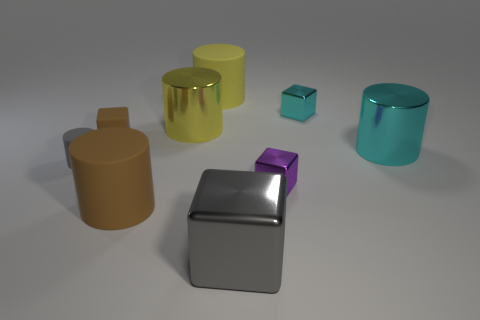Subtract all big brown matte cylinders. How many cylinders are left? 4 Subtract 1 blocks. How many blocks are left? 3 Subtract all brown cylinders. How many cylinders are left? 4 Subtract all brown cylinders. Subtract all purple cubes. How many cylinders are left? 4 Subtract all cubes. How many objects are left? 5 Subtract 1 cyan cylinders. How many objects are left? 8 Subtract all brown matte blocks. Subtract all gray things. How many objects are left? 6 Add 1 tiny matte cubes. How many tiny matte cubes are left? 2 Add 8 tiny purple matte cylinders. How many tiny purple matte cylinders exist? 8 